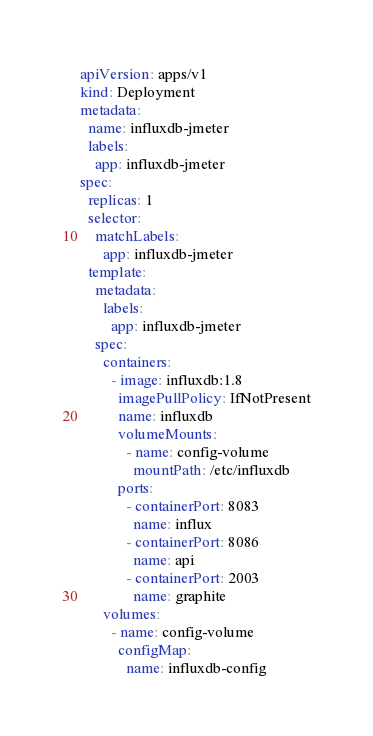<code> <loc_0><loc_0><loc_500><loc_500><_YAML_>apiVersion: apps/v1
kind: Deployment
metadata:
  name: influxdb-jmeter
  labels:
    app: influxdb-jmeter
spec:
  replicas: 1
  selector:
    matchLabels:
      app: influxdb-jmeter
  template:
    metadata:
      labels:
        app: influxdb-jmeter
    spec:
      containers:
        - image: influxdb:1.8
          imagePullPolicy: IfNotPresent
          name: influxdb
          volumeMounts:
            - name: config-volume
              mountPath: /etc/influxdb
          ports:
            - containerPort: 8083
              name: influx
            - containerPort: 8086
              name: api
            - containerPort: 2003
              name: graphite
      volumes:
        - name: config-volume
          configMap:
            name: influxdb-config
</code> 